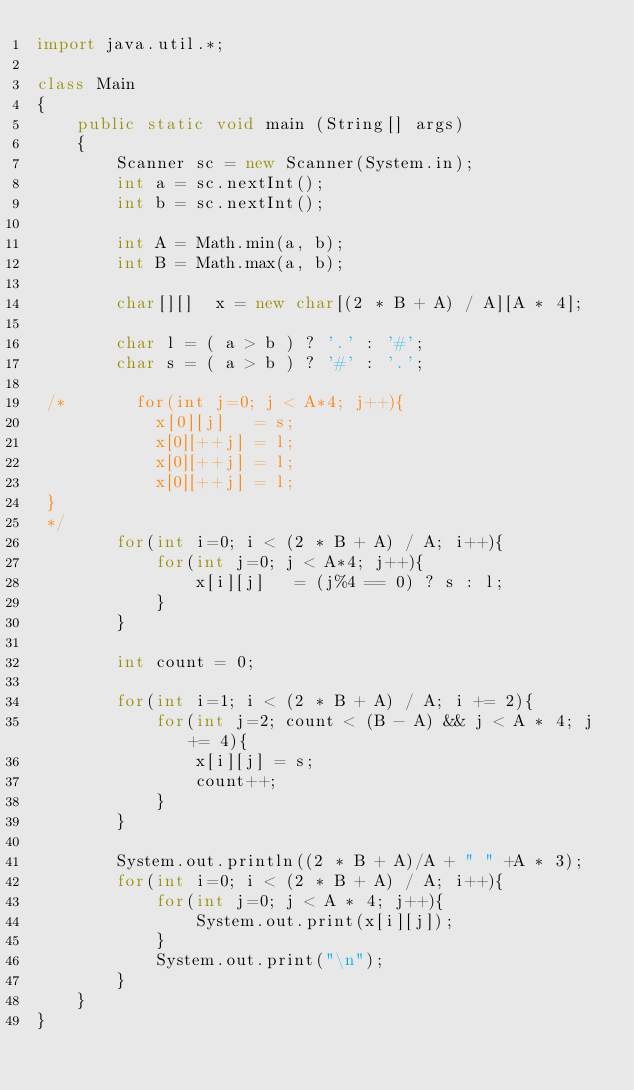Convert code to text. <code><loc_0><loc_0><loc_500><loc_500><_Java_>import java.util.*;

class Main
{
    public static void main (String[] args)
    {
        Scanner sc = new Scanner(System.in);
        int a = sc.nextInt();
        int b = sc.nextInt();

        int A = Math.min(a, b);
        int B = Math.max(a, b);

        char[][]  x = new char[(2 * B + A) / A][A * 4]; 

        char l = ( a > b ) ? '.' : '#';
        char s = ( a > b ) ? '#' : '.';

 /*       for(int j=0; j < A*4; j++){
            x[0][j]   = s;
            x[0][++j] = l;
            x[0][++j] = l;
            x[0][++j] = l;
 }
 */
        for(int i=0; i < (2 * B + A) / A; i++){
            for(int j=0; j < A*4; j++){
                x[i][j]   = (j%4 == 0) ? s : l;
            }
        }

        int count = 0;

        for(int i=1; i < (2 * B + A) / A; i += 2){
            for(int j=2; count < (B - A) && j < A * 4; j += 4){
                x[i][j] = s;
                count++;
            }
        }

        System.out.println((2 * B + A)/A + " " +A * 3);
        for(int i=0; i < (2 * B + A) / A; i++){
            for(int j=0; j < A * 4; j++){
                System.out.print(x[i][j]);
            }
            System.out.print("\n");
        }
    }
}

</code> 